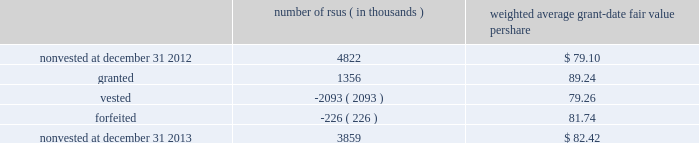Note 12 2013 stock-based compensation during 2013 , 2012 , and 2011 , we recorded non-cash stock-based compensation expense totaling $ 189 million , $ 167 million , and $ 157 million , which is included as a component of other unallocated costs on our statements of earnings .
The net impact to earnings for the respective years was $ 122 million , $ 108 million , and $ 101 million .
As of december 31 , 2013 , we had $ 132 million of unrecognized compensation cost related to nonvested awards , which is expected to be recognized over a weighted average period of 1.5 years .
We received cash from the exercise of stock options totaling $ 827 million , $ 440 million , and $ 116 million during 2013 , 2012 , and 2011 .
In addition , our income tax liabilities for 2013 , 2012 , and 2011 were reduced by $ 158 million , $ 96 million , and $ 56 million due to recognized tax benefits on stock-based compensation arrangements .
Stock-based compensation plans under plans approved by our stockholders , we are authorized to grant key employees stock-based incentive awards , including options to purchase common stock , stock appreciation rights , restricted stock units ( rsus ) , performance stock units ( psus ) , or other stock units .
The exercise price of options to purchase common stock may not be less than the fair market value of our stock on the date of grant .
No award of stock options may become fully vested prior to the third anniversary of the grant , and no portion of a stock option grant may become vested in less than one year .
The minimum vesting period for restricted stock or stock units payable in stock is three years .
Award agreements may provide for shorter or pro-rated vesting periods or vesting following termination of employment in the case of death , disability , divestiture , retirement , change of control , or layoff .
The maximum term of a stock option or any other award is 10 years .
At december 31 , 2013 , inclusive of the shares reserved for outstanding stock options , rsus and psus , we had 20.4 million shares reserved for issuance under the plans .
At december 31 , 2013 , 4.7 million of the shares reserved for issuance remained available for grant under our stock-based compensation plans .
We issue new shares upon the exercise of stock options or when restrictions on rsus and psus have been satisfied .
The table summarizes activity related to nonvested rsus during 2013 : number of rsus ( in thousands ) weighted average grant-date fair value per share .
Rsus are valued based on the fair value of our common stock on the date of grant .
Employees who are granted rsus receive the right to receive shares of stock after completion of the vesting period , however , the shares are not issued , and the employees cannot sell or transfer shares prior to vesting and have no voting rights until the rsus vest , generally three years from the date of the award .
Employees who are granted rsus receive dividend-equivalent cash payments only upon vesting .
For these rsu awards , the grant-date fair value is equal to the closing market price of our common stock on the date of grant less a discount to reflect the delay in payment of dividend-equivalent cash payments .
We recognize the grant-date fair value of rsus , less estimated forfeitures , as compensation expense ratably over the requisite service period , which beginning with the rsus granted in 2013 is shorter than the vesting period if the employee is retirement eligible on the date of grant or will become retirement eligible before the end of the vesting period .
Stock options we generally recognize compensation cost for stock options ratably over the three-year vesting period .
At december 31 , 2013 and 2012 , there were 10.2 million ( weighted average exercise price of $ 83.65 ) and 20.6 million ( weighted average exercise price of $ 83.15 ) stock options outstanding .
Stock options outstanding at december 31 , 2013 have a weighted average remaining contractual life of approximately five years and an aggregate intrinsic value of $ 663 million , and we expect nearly all of these stock options to vest .
Of the stock options outstanding , 7.7 million ( weighted average exercise price of $ 84.37 ) have vested as of december 31 , 2013 and those stock options have a weighted average remaining contractual life of approximately four years and an aggregate intrinsic value of $ 497 million .
There were 10.1 million ( weighted average exercise price of $ 82.72 ) stock options exercised during 2013 .
We did not grant stock options to employees during 2013. .
What was the ratio f the cash received from the exercise of stock options in 2013 to 2012? 
Computations: (827 / 440)
Answer: 1.87955. 